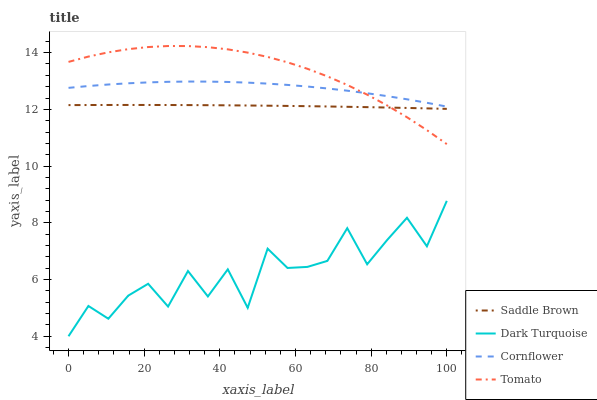Does Saddle Brown have the minimum area under the curve?
Answer yes or no. No. Does Saddle Brown have the maximum area under the curve?
Answer yes or no. No. Is Dark Turquoise the smoothest?
Answer yes or no. No. Is Saddle Brown the roughest?
Answer yes or no. No. Does Saddle Brown have the lowest value?
Answer yes or no. No. Does Saddle Brown have the highest value?
Answer yes or no. No. Is Dark Turquoise less than Cornflower?
Answer yes or no. Yes. Is Cornflower greater than Saddle Brown?
Answer yes or no. Yes. Does Dark Turquoise intersect Cornflower?
Answer yes or no. No. 